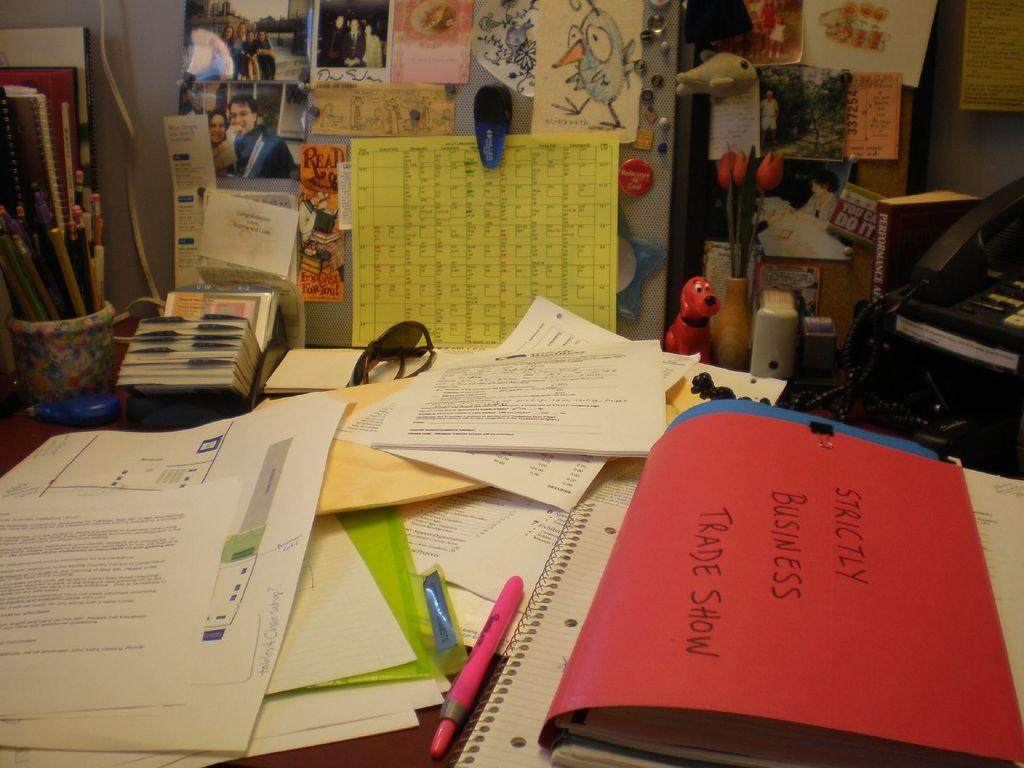<image>
Write a terse but informative summary of the picture. A red binder on a messy desk is labelled STRICTLY BUSINESS TRADE SHOW. 